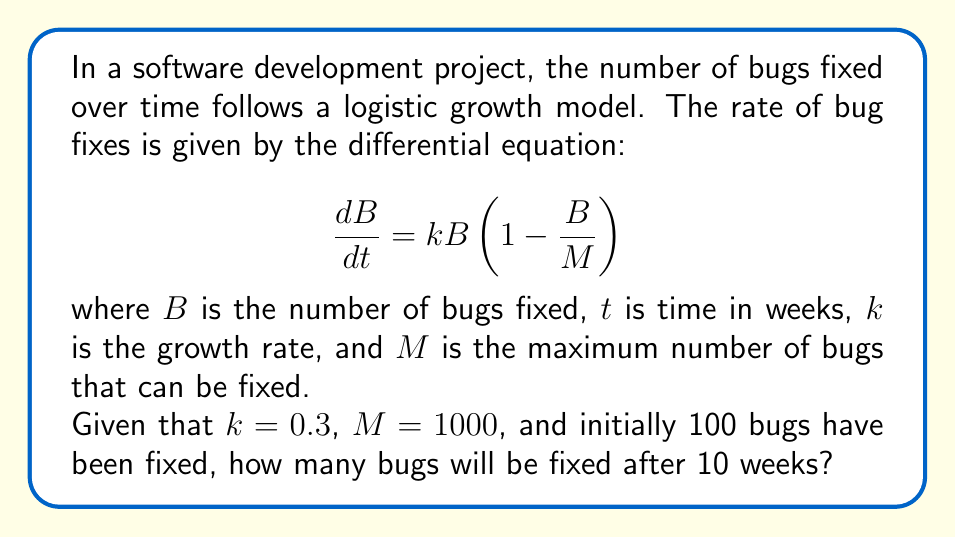Give your solution to this math problem. To solve this problem, we need to use the solution to the logistic differential equation. The general solution is:

$$B(t) = \frac{M}{1 + (\frac{M}{B_0} - 1)e^{-kt}}$$

where $B_0$ is the initial number of bugs fixed.

Given:
- $k = 0.3$ (growth rate)
- $M = 1000$ (maximum number of bugs)
- $B_0 = 100$ (initial number of bugs fixed)
- $t = 10$ (time in weeks)

Let's substitute these values into the equation:

$$B(10) = \frac{1000}{1 + (\frac{1000}{100} - 1)e^{-0.3 \cdot 10}}$$

$$= \frac{1000}{1 + 9e^{-3}}$$

Now, let's calculate this step by step:

1. Calculate $e^{-3}$:
   $e^{-3} \approx 0.0498$

2. Multiply by 9:
   $9 \cdot 0.0498 \approx 0.4482$

3. Add 1 to the denominator:
   $1 + 0.4482 = 1.4482$

4. Divide 1000 by this result:
   $\frac{1000}{1.4482} \approx 690.51$

Rounding to the nearest whole number (as we can't have a fraction of a bug), we get 691 bugs fixed after 10 weeks.
Answer: 691 bugs 